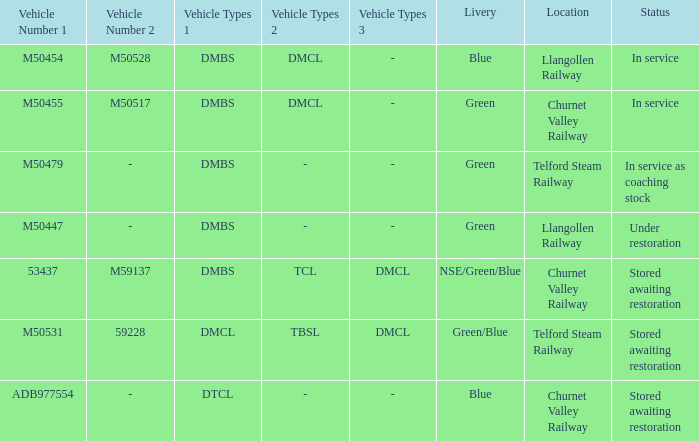In service as coaching stock, which livery holds that status? Green. 